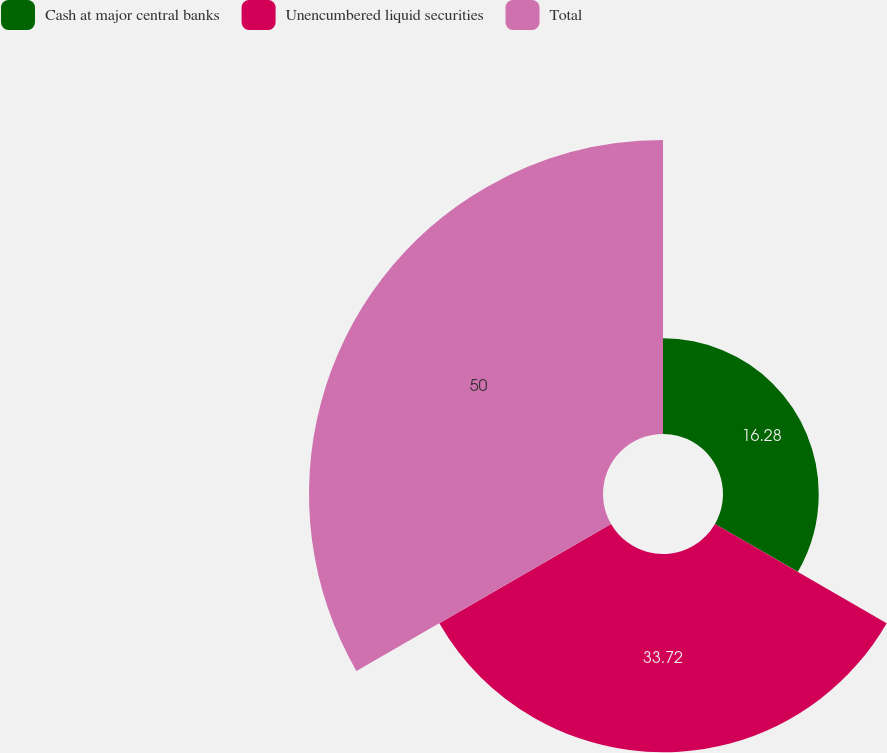Convert chart to OTSL. <chart><loc_0><loc_0><loc_500><loc_500><pie_chart><fcel>Cash at major central banks<fcel>Unencumbered liquid securities<fcel>Total<nl><fcel>16.28%<fcel>33.72%<fcel>50.0%<nl></chart> 